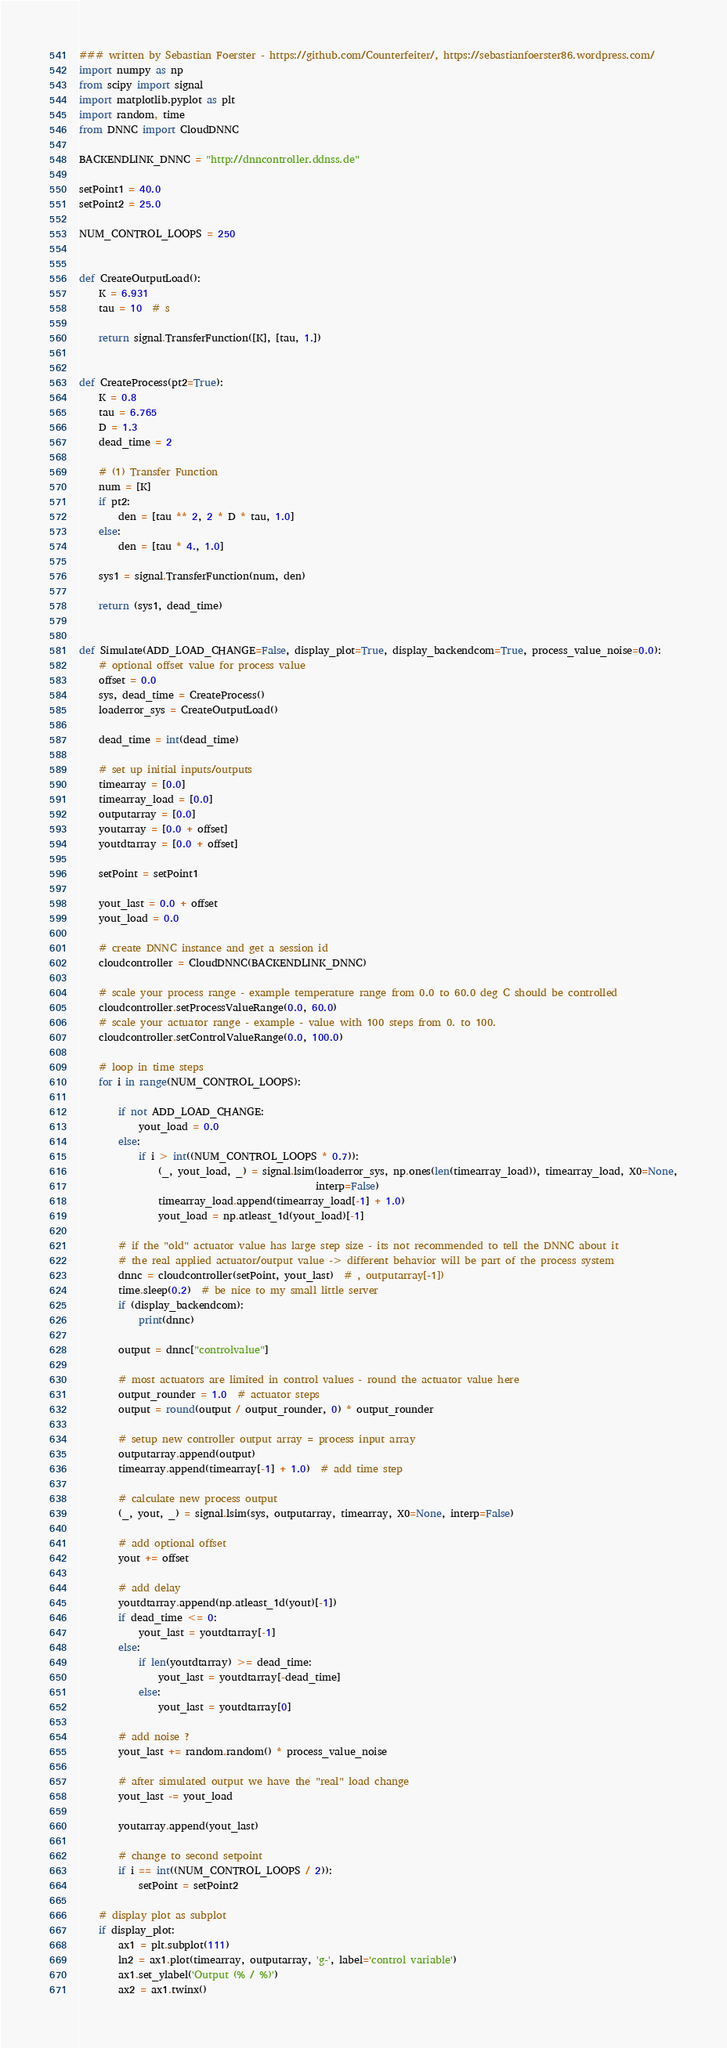<code> <loc_0><loc_0><loc_500><loc_500><_Python_>### written by Sebastian Foerster - https://github.com/Counterfeiter/, https://sebastianfoerster86.wordpress.com/
import numpy as np
from scipy import signal
import matplotlib.pyplot as plt
import random, time
from DNNC import CloudDNNC

BACKENDLINK_DNNC = "http://dnncontroller.ddnss.de"

setPoint1 = 40.0
setPoint2 = 25.0

NUM_CONTROL_LOOPS = 250


def CreateOutputLoad():
    K = 6.931
    tau = 10  # s

    return signal.TransferFunction([K], [tau, 1.])


def CreateProcess(pt2=True):
    K = 0.8
    tau = 6.765
    D = 1.3
    dead_time = 2

    # (1) Transfer Function
    num = [K]
    if pt2:
        den = [tau ** 2, 2 * D * tau, 1.0]
    else:
        den = [tau * 4., 1.0]

    sys1 = signal.TransferFunction(num, den)

    return (sys1, dead_time)


def Simulate(ADD_LOAD_CHANGE=False, display_plot=True, display_backendcom=True, process_value_noise=0.0):
    # optional offset value for process value
    offset = 0.0
    sys, dead_time = CreateProcess()
    loaderror_sys = CreateOutputLoad()

    dead_time = int(dead_time)

    # set up initial inputs/outputs
    timearray = [0.0]
    timearray_load = [0.0]
    outputarray = [0.0]
    youtarray = [0.0 + offset]
    youtdtarray = [0.0 + offset]

    setPoint = setPoint1

    yout_last = 0.0 + offset
    yout_load = 0.0

    # create DNNC instance and get a session id
    cloudcontroller = CloudDNNC(BACKENDLINK_DNNC)

    # scale your process range - example temperature range from 0.0 to 60.0 deg C should be controlled
    cloudcontroller.setProcessValueRange(0.0, 60.0)
    # scale your actuator range - example - value with 100 steps from 0. to 100.
    cloudcontroller.setControlValueRange(0.0, 100.0)

    # loop in time steps
    for i in range(NUM_CONTROL_LOOPS):

        if not ADD_LOAD_CHANGE:
            yout_load = 0.0
        else:
            if i > int((NUM_CONTROL_LOOPS * 0.7)):
                (_, yout_load, _) = signal.lsim(loaderror_sys, np.ones(len(timearray_load)), timearray_load, X0=None,
                                                interp=False)
                timearray_load.append(timearray_load[-1] + 1.0)
                yout_load = np.atleast_1d(yout_load)[-1]

        # if the "old" actuator value has large step size - its not recommended to tell the DNNC about it
        # the real applied actuator/output value -> different behavior will be part of the process system
        dnnc = cloudcontroller(setPoint, yout_last)  # , outputarray[-1])
        time.sleep(0.2)  # be nice to my small little server
        if (display_backendcom):
            print(dnnc)

        output = dnnc["controlvalue"]

        # most actuators are limited in control values - round the actuator value here
        output_rounder = 1.0  # actuator steps
        output = round(output / output_rounder, 0) * output_rounder

        # setup new controller output array = process input array
        outputarray.append(output)
        timearray.append(timearray[-1] + 1.0)  # add time step

        # calculate new process output
        (_, yout, _) = signal.lsim(sys, outputarray, timearray, X0=None, interp=False)

        # add optional offset
        yout += offset

        # add delay
        youtdtarray.append(np.atleast_1d(yout)[-1])
        if dead_time <= 0:
            yout_last = youtdtarray[-1]
        else:
            if len(youtdtarray) >= dead_time:
                yout_last = youtdtarray[-dead_time]
            else:
                yout_last = youtdtarray[0]

        # add noise ?
        yout_last += random.random() * process_value_noise

        # after simulated output we have the "real" load change
        yout_last -= yout_load

        youtarray.append(yout_last)

        # change to second setpoint
        if i == int((NUM_CONTROL_LOOPS / 2)):
            setPoint = setPoint2

    # display plot as subplot
    if display_plot:
        ax1 = plt.subplot(111)
        ln2 = ax1.plot(timearray, outputarray, 'g-', label='control variable')
        ax1.set_ylabel('Output (% / %)')
        ax2 = ax1.twinx()</code> 